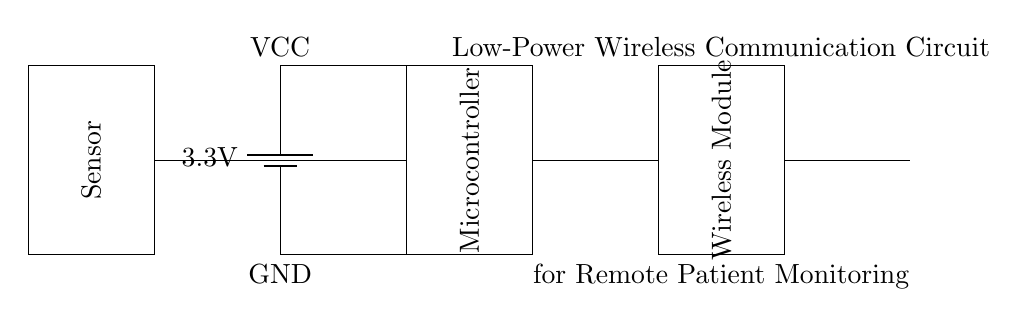What is the voltage of the power supply? The voltage is determined by the label next to the battery component in the circuit. It shows that the power supply is providing 3.3 volts.
Answer: 3.3 volts What does the rectangle labeled 'Microcontroller' represent? The rectangle in the circuit diagram signifies the microcontroller, which is responsible for processing data and controlling the whole system's operation. The label confirms its function.
Answer: Microcontroller How many major components are in this circuit? By counting the distinct parts in the circuit (battery, microcontroller, wireless module, antenna, and sensor), we can determine that there are five major components.
Answer: Five What is the main function of the wireless module? The wireless module is used for transmitting and receiving data wirelessly, allowing for communication between the remote sensor and the monitoring device. This function is generally known in circuit applications involving patient monitoring.
Answer: Transmitting data What connects the sensor to the microcontroller? The connection between the sensor and the microcontroller can be identified as a line drawn from the sensor's output to the microcontroller's input. This indicates data flow from the sensor to the microcontroller.
Answer: A wire Which component is responsible for collecting patient data? The sensor is specifically designed to collect data related to patient health, as indicated by its labeling within the circuit diagram.
Answer: Sensor 